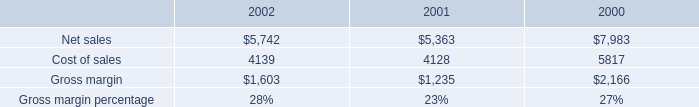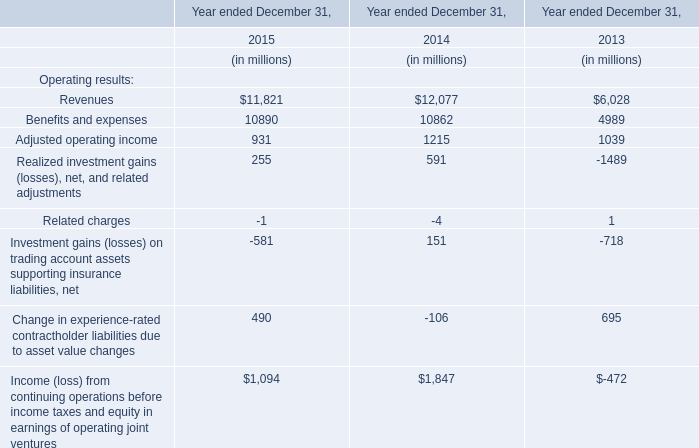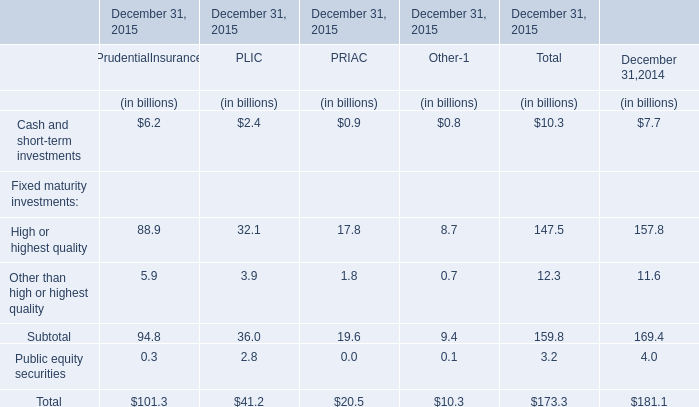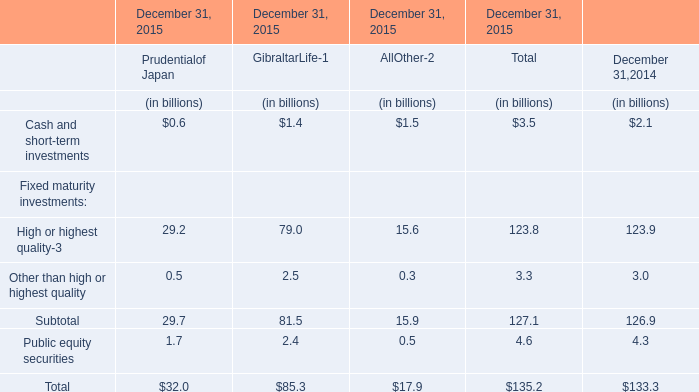What do all elements sum up in 2014 , excluding Other than high or highest quality and Public equity securities? (in billion) 
Computations: (2.1 + 123.9)
Answer: 126.0. 